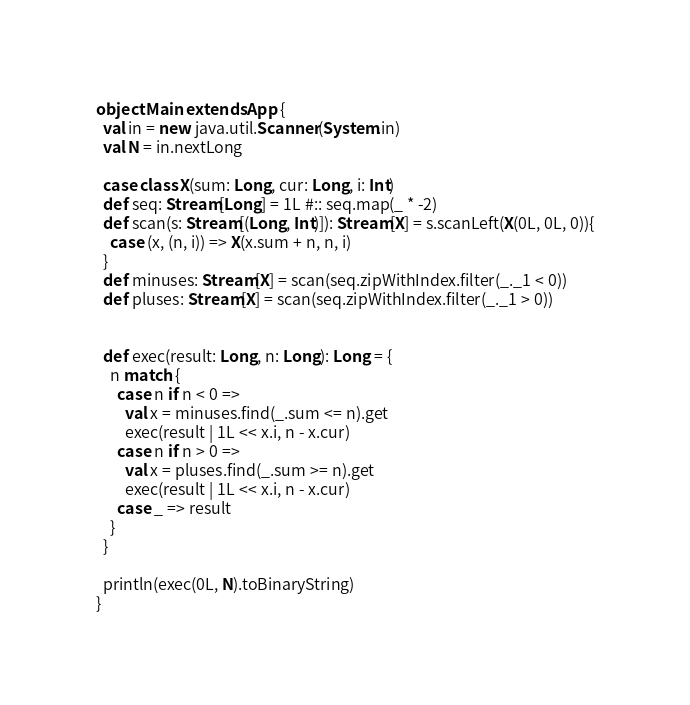Convert code to text. <code><loc_0><loc_0><loc_500><loc_500><_Scala_>object Main extends App {
  val in = new java.util.Scanner(System.in)
  val N = in.nextLong

  case class X(sum: Long, cur: Long, i: Int)
  def seq: Stream[Long] = 1L #:: seq.map(_ * -2)
  def scan(s: Stream[(Long, Int)]): Stream[X] = s.scanLeft(X(0L, 0L, 0)){
    case (x, (n, i)) => X(x.sum + n, n, i)
  }
  def minuses: Stream[X] = scan(seq.zipWithIndex.filter(_._1 < 0))
  def pluses: Stream[X] = scan(seq.zipWithIndex.filter(_._1 > 0))


  def exec(result: Long, n: Long): Long = {
    n match {
      case n if n < 0 =>
        val x = minuses.find(_.sum <= n).get
        exec(result | 1L << x.i, n - x.cur)
      case n if n > 0 =>
        val x = pluses.find(_.sum >= n).get
        exec(result | 1L << x.i, n - x.cur)
      case _ => result
    }
  }

  println(exec(0L, N).toBinaryString)
}</code> 